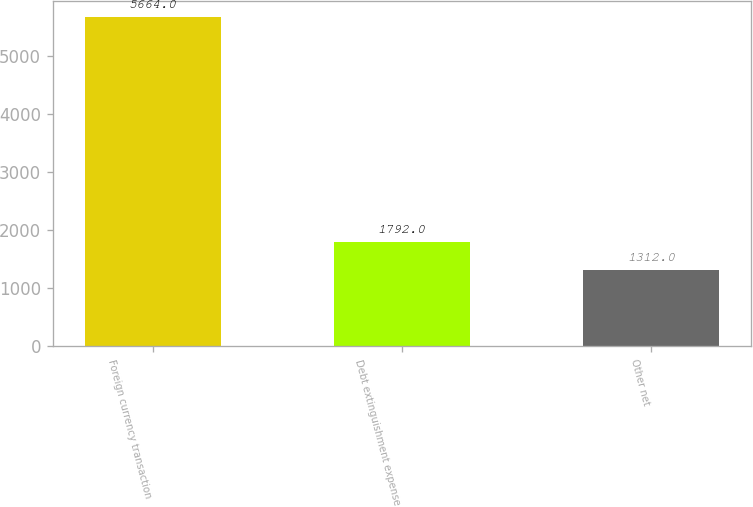Convert chart to OTSL. <chart><loc_0><loc_0><loc_500><loc_500><bar_chart><fcel>Foreign currency transaction<fcel>Debt extinguishment expense<fcel>Other net<nl><fcel>5664<fcel>1792<fcel>1312<nl></chart> 